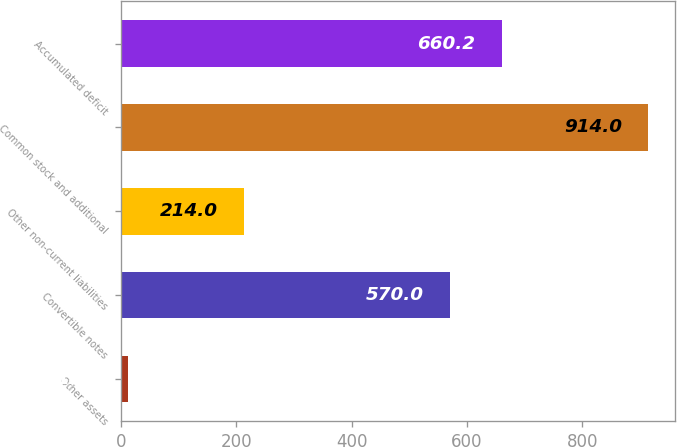Convert chart. <chart><loc_0><loc_0><loc_500><loc_500><bar_chart><fcel>Other assets<fcel>Convertible notes<fcel>Other non-current liabilities<fcel>Common stock and additional<fcel>Accumulated deficit<nl><fcel>12<fcel>570<fcel>214<fcel>914<fcel>660.2<nl></chart> 